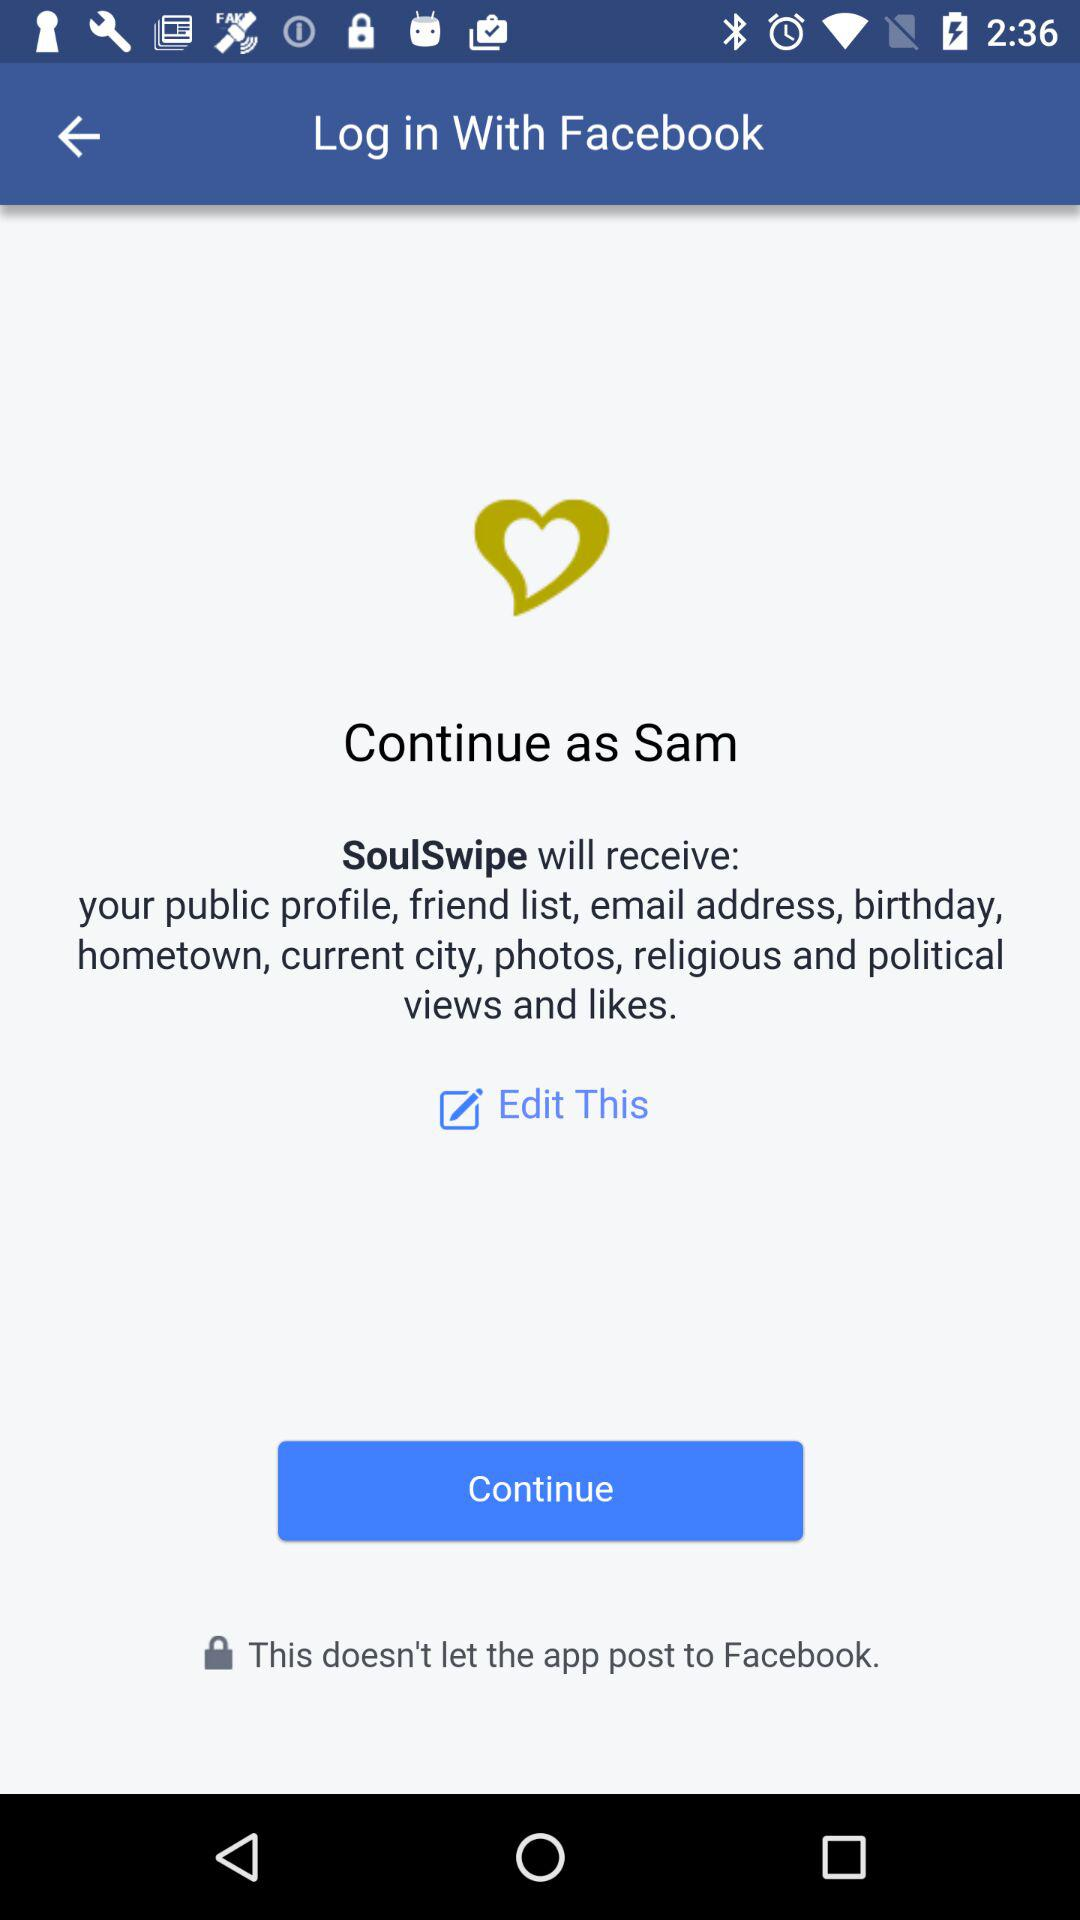What is the name of the user? The name of the user is Sam. 